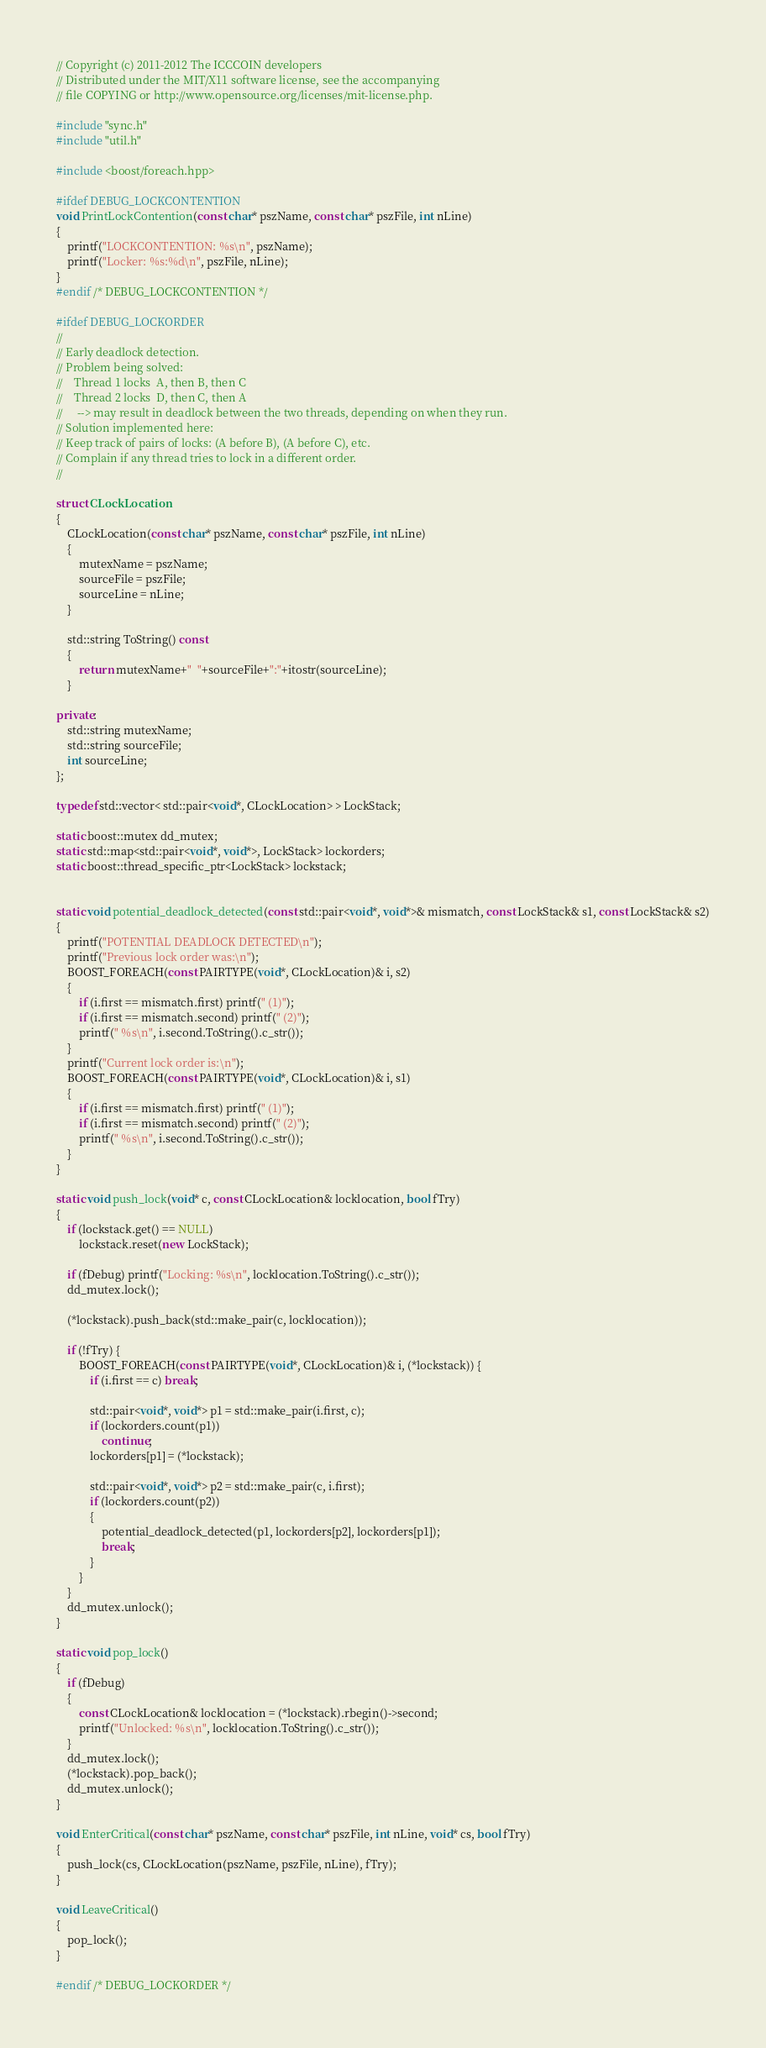Convert code to text. <code><loc_0><loc_0><loc_500><loc_500><_C++_>// Copyright (c) 2011-2012 The ICCCOIN developers
// Distributed under the MIT/X11 software license, see the accompanying
// file COPYING or http://www.opensource.org/licenses/mit-license.php.

#include "sync.h"
#include "util.h"

#include <boost/foreach.hpp>

#ifdef DEBUG_LOCKCONTENTION
void PrintLockContention(const char* pszName, const char* pszFile, int nLine)
{
    printf("LOCKCONTENTION: %s\n", pszName);
    printf("Locker: %s:%d\n", pszFile, nLine);
}
#endif /* DEBUG_LOCKCONTENTION */

#ifdef DEBUG_LOCKORDER
//
// Early deadlock detection.
// Problem being solved:
//    Thread 1 locks  A, then B, then C
//    Thread 2 locks  D, then C, then A
//     --> may result in deadlock between the two threads, depending on when they run.
// Solution implemented here:
// Keep track of pairs of locks: (A before B), (A before C), etc.
// Complain if any thread tries to lock in a different order.
//

struct CLockLocation
{
    CLockLocation(const char* pszName, const char* pszFile, int nLine)
    {
        mutexName = pszName;
        sourceFile = pszFile;
        sourceLine = nLine;
    }

    std::string ToString() const
    {
        return mutexName+"  "+sourceFile+":"+itostr(sourceLine);
    }

private:
    std::string mutexName;
    std::string sourceFile;
    int sourceLine;
};

typedef std::vector< std::pair<void*, CLockLocation> > LockStack;

static boost::mutex dd_mutex;
static std::map<std::pair<void*, void*>, LockStack> lockorders;
static boost::thread_specific_ptr<LockStack> lockstack;


static void potential_deadlock_detected(const std::pair<void*, void*>& mismatch, const LockStack& s1, const LockStack& s2)
{
    printf("POTENTIAL DEADLOCK DETECTED\n");
    printf("Previous lock order was:\n");
    BOOST_FOREACH(const PAIRTYPE(void*, CLockLocation)& i, s2)
    {
        if (i.first == mismatch.first) printf(" (1)");
        if (i.first == mismatch.second) printf(" (2)");
        printf(" %s\n", i.second.ToString().c_str());
    }
    printf("Current lock order is:\n");
    BOOST_FOREACH(const PAIRTYPE(void*, CLockLocation)& i, s1)
    {
        if (i.first == mismatch.first) printf(" (1)");
        if (i.first == mismatch.second) printf(" (2)");
        printf(" %s\n", i.second.ToString().c_str());
    }
}

static void push_lock(void* c, const CLockLocation& locklocation, bool fTry)
{
    if (lockstack.get() == NULL)
        lockstack.reset(new LockStack);

    if (fDebug) printf("Locking: %s\n", locklocation.ToString().c_str());
    dd_mutex.lock();

    (*lockstack).push_back(std::make_pair(c, locklocation));

    if (!fTry) {
        BOOST_FOREACH(const PAIRTYPE(void*, CLockLocation)& i, (*lockstack)) {
            if (i.first == c) break;

            std::pair<void*, void*> p1 = std::make_pair(i.first, c);
            if (lockorders.count(p1))
                continue;
            lockorders[p1] = (*lockstack);

            std::pair<void*, void*> p2 = std::make_pair(c, i.first);
            if (lockorders.count(p2))
            {
                potential_deadlock_detected(p1, lockorders[p2], lockorders[p1]);
                break;
            }
        }
    }
    dd_mutex.unlock();
}

static void pop_lock()
{
    if (fDebug)
    {
        const CLockLocation& locklocation = (*lockstack).rbegin()->second;
        printf("Unlocked: %s\n", locklocation.ToString().c_str());
    }
    dd_mutex.lock();
    (*lockstack).pop_back();
    dd_mutex.unlock();
}

void EnterCritical(const char* pszName, const char* pszFile, int nLine, void* cs, bool fTry)
{
    push_lock(cs, CLockLocation(pszName, pszFile, nLine), fTry);
}

void LeaveCritical()
{
    pop_lock();
}

#endif /* DEBUG_LOCKORDER */
</code> 